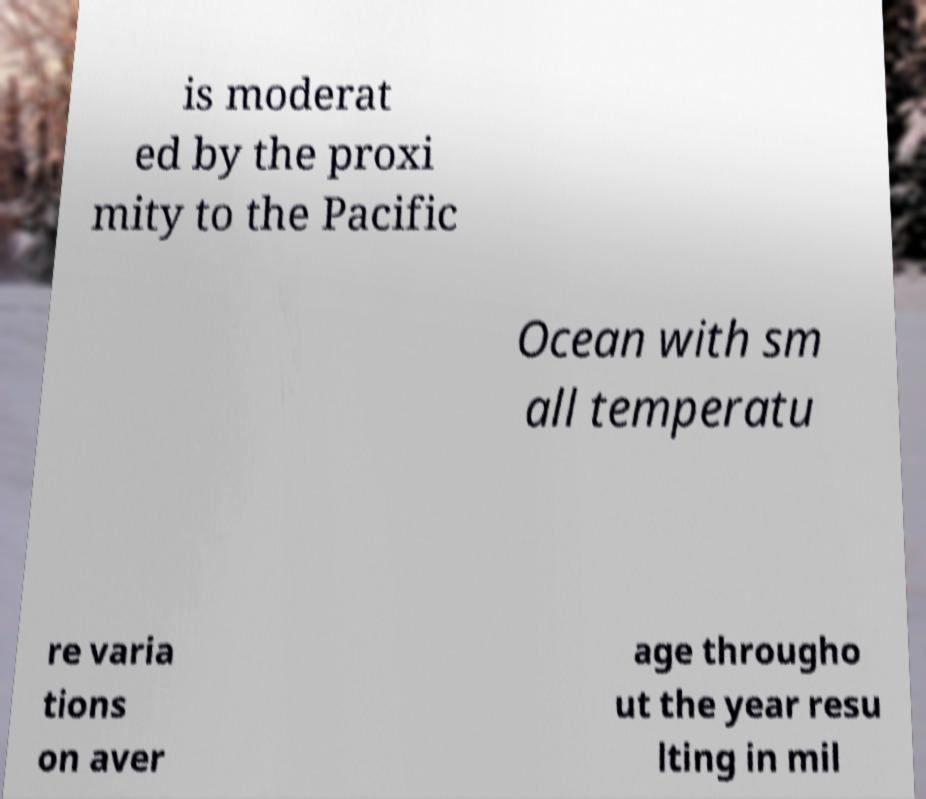Can you accurately transcribe the text from the provided image for me? is moderat ed by the proxi mity to the Pacific Ocean with sm all temperatu re varia tions on aver age througho ut the year resu lting in mil 